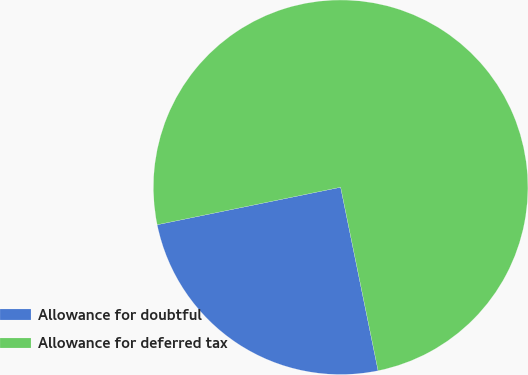<chart> <loc_0><loc_0><loc_500><loc_500><pie_chart><fcel>Allowance for doubtful<fcel>Allowance for deferred tax<nl><fcel>25.0%<fcel>75.0%<nl></chart> 